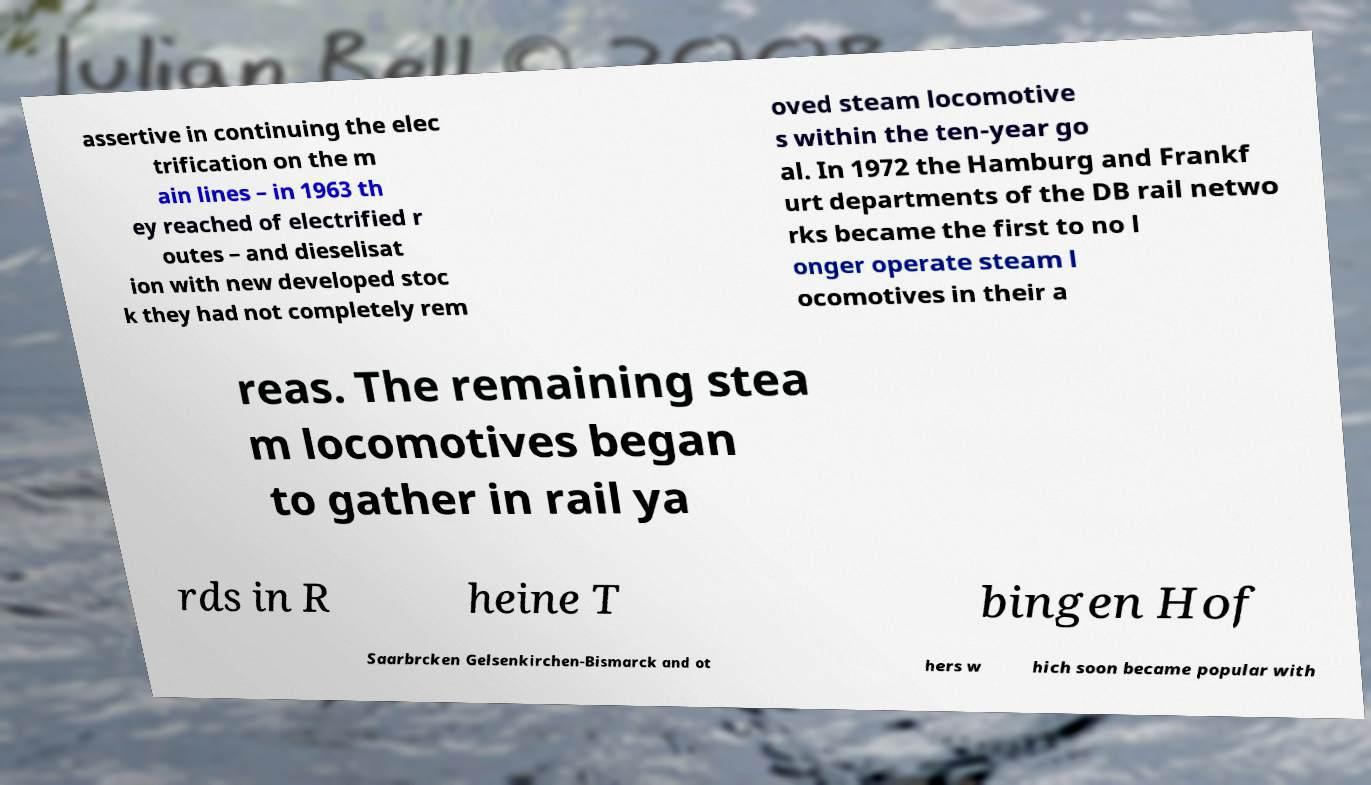There's text embedded in this image that I need extracted. Can you transcribe it verbatim? assertive in continuing the elec trification on the m ain lines – in 1963 th ey reached of electrified r outes – and dieselisat ion with new developed stoc k they had not completely rem oved steam locomotive s within the ten-year go al. In 1972 the Hamburg and Frankf urt departments of the DB rail netwo rks became the first to no l onger operate steam l ocomotives in their a reas. The remaining stea m locomotives began to gather in rail ya rds in R heine T bingen Hof Saarbrcken Gelsenkirchen-Bismarck and ot hers w hich soon became popular with 